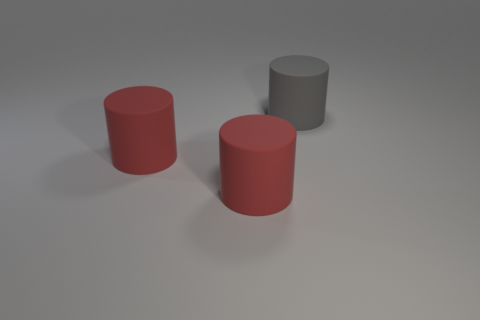Add 2 large things. How many objects exist? 5 Subtract all big red cylinders. How many cylinders are left? 1 Subtract all red cylinders. How many cylinders are left? 1 Subtract 2 cylinders. How many cylinders are left? 1 Subtract all brown cylinders. Subtract all gray blocks. How many cylinders are left? 3 Subtract all yellow spheres. How many gray cylinders are left? 1 Subtract all big gray things. Subtract all gray rubber objects. How many objects are left? 1 Add 1 red cylinders. How many red cylinders are left? 3 Add 3 big blue matte cylinders. How many big blue matte cylinders exist? 3 Subtract 0 yellow cubes. How many objects are left? 3 